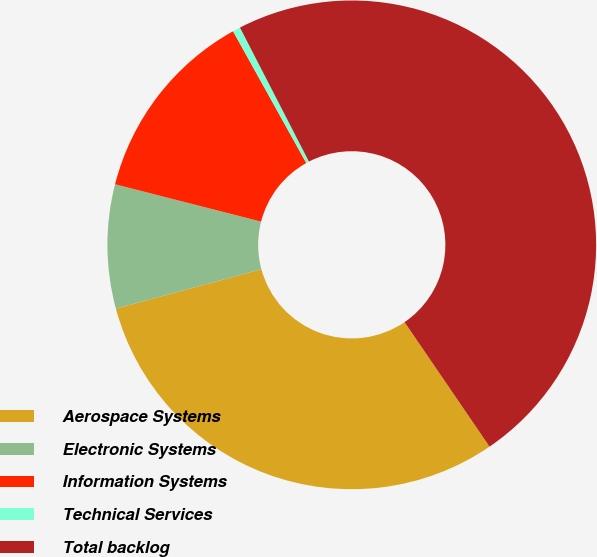<chart> <loc_0><loc_0><loc_500><loc_500><pie_chart><fcel>Aerospace Systems<fcel>Electronic Systems<fcel>Information Systems<fcel>Technical Services<fcel>Total backlog<nl><fcel>30.33%<fcel>8.19%<fcel>12.94%<fcel>0.51%<fcel>48.03%<nl></chart> 